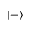Convert formula to latex. <formula><loc_0><loc_0><loc_500><loc_500>\left | - \right \rangle</formula> 